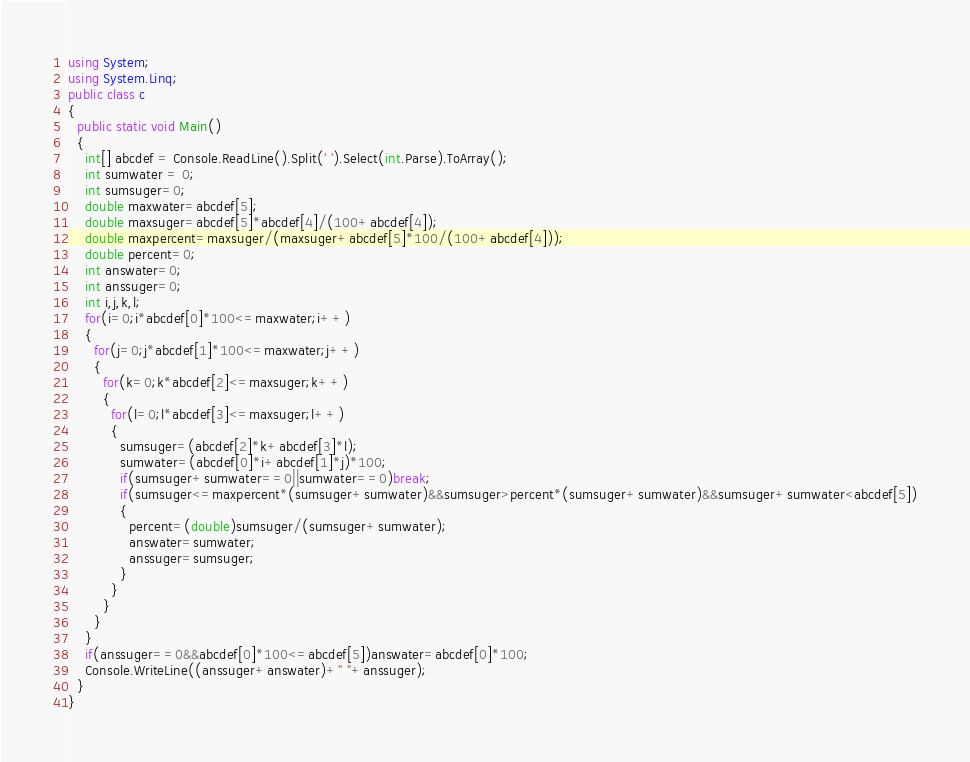Convert code to text. <code><loc_0><loc_0><loc_500><loc_500><_C#_>using System;
using System.Linq;
public class c
{
  public static void Main()
  {
    int[] abcdef = Console.ReadLine().Split(' ').Select(int.Parse).ToArray();
    int sumwater = 0;
    int sumsuger=0;
    double maxwater=abcdef[5];
    double maxsuger=abcdef[5]*abcdef[4]/(100+abcdef[4]);
    double maxpercent=maxsuger/(maxsuger+abcdef[5]*100/(100+abcdef[4]));
    double percent=0;
    int answater=0;
    int anssuger=0;
    int i,j,k,l;
    for(i=0;i*abcdef[0]*100<=maxwater;i++)
    {
      for(j=0;j*abcdef[1]*100<=maxwater;j++)
      {
        for(k=0;k*abcdef[2]<=maxsuger;k++)
        {
          for(l=0;l*abcdef[3]<=maxsuger;l++)
          {
            sumsuger=(abcdef[2]*k+abcdef[3]*l);
            sumwater=(abcdef[0]*i+abcdef[1]*j)*100;
            if(sumsuger+sumwater==0||sumwater==0)break;
            if(sumsuger<=maxpercent*(sumsuger+sumwater)&&sumsuger>percent*(sumsuger+sumwater)&&sumsuger+sumwater<abcdef[5])
            {
              percent=(double)sumsuger/(sumsuger+sumwater);
              answater=sumwater;
              anssuger=sumsuger;     
            }
          }
        }
      }
    }
    if(anssuger==0&&abcdef[0]*100<=abcdef[5])answater=abcdef[0]*100;
    Console.WriteLine((anssuger+answater)+" "+anssuger);
  }
}</code> 